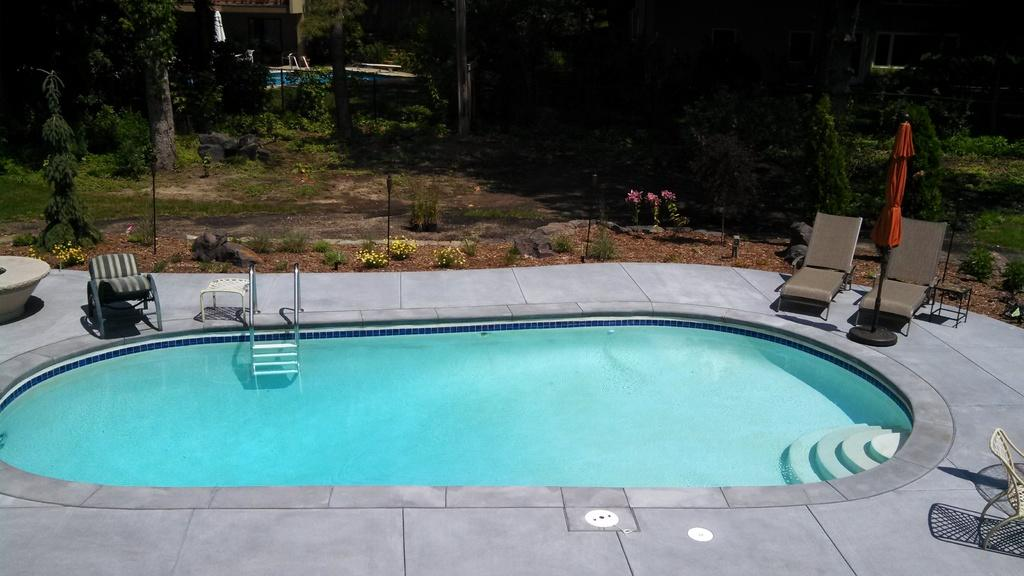What is the main feature in the image? There is a swimming pool in the image. What can be seen in the background of the image? There are chairs in the background of the image. What colors are the flowers in the image? The flowers in the image are in pink and yellow colors. What type of vegetation is present in the image? There are trees with green leaves in the image. What type of rake is being used to clean the pool in the image? There is no rake present in the image, and the pool is not being cleaned. How many men are visible in the image? There is no mention of men in the image, so we cannot determine their presence or number. 